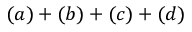Convert formula to latex. <formula><loc_0><loc_0><loc_500><loc_500>( a ) + ( b ) + ( c ) + ( d )</formula> 